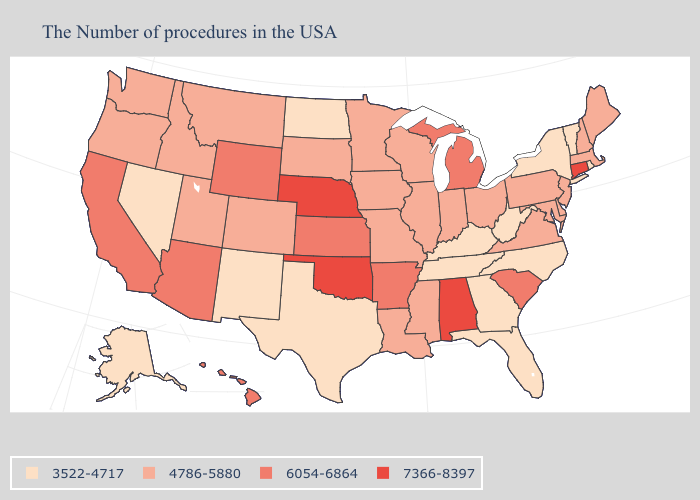Among the states that border Indiana , does Illinois have the highest value?
Write a very short answer. No. Does the first symbol in the legend represent the smallest category?
Quick response, please. Yes. Does Iowa have the highest value in the USA?
Answer briefly. No. What is the value of Arizona?
Concise answer only. 6054-6864. What is the value of South Dakota?
Write a very short answer. 4786-5880. What is the highest value in the South ?
Keep it brief. 7366-8397. Does the map have missing data?
Be succinct. No. Name the states that have a value in the range 7366-8397?
Give a very brief answer. Connecticut, Alabama, Nebraska, Oklahoma. Among the states that border New Mexico , which have the highest value?
Be succinct. Oklahoma. What is the value of South Dakota?
Write a very short answer. 4786-5880. Name the states that have a value in the range 3522-4717?
Give a very brief answer. Rhode Island, Vermont, New York, North Carolina, West Virginia, Florida, Georgia, Kentucky, Tennessee, Texas, North Dakota, New Mexico, Nevada, Alaska. Name the states that have a value in the range 4786-5880?
Answer briefly. Maine, Massachusetts, New Hampshire, New Jersey, Delaware, Maryland, Pennsylvania, Virginia, Ohio, Indiana, Wisconsin, Illinois, Mississippi, Louisiana, Missouri, Minnesota, Iowa, South Dakota, Colorado, Utah, Montana, Idaho, Washington, Oregon. Name the states that have a value in the range 7366-8397?
Short answer required. Connecticut, Alabama, Nebraska, Oklahoma. Does New Hampshire have a higher value than Texas?
Concise answer only. Yes. What is the highest value in the Northeast ?
Short answer required. 7366-8397. 